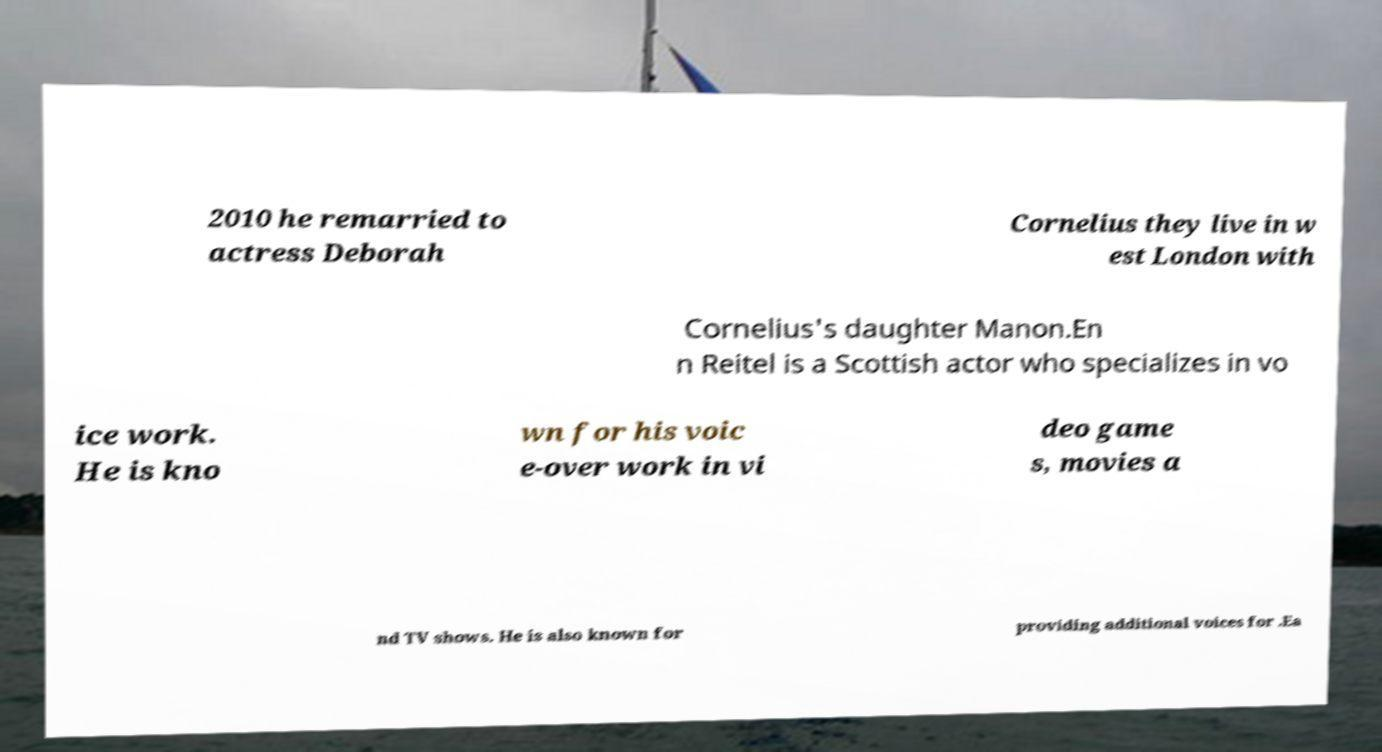For documentation purposes, I need the text within this image transcribed. Could you provide that? 2010 he remarried to actress Deborah Cornelius they live in w est London with Cornelius's daughter Manon.En n Reitel is a Scottish actor who specializes in vo ice work. He is kno wn for his voic e-over work in vi deo game s, movies a nd TV shows. He is also known for providing additional voices for .Ea 